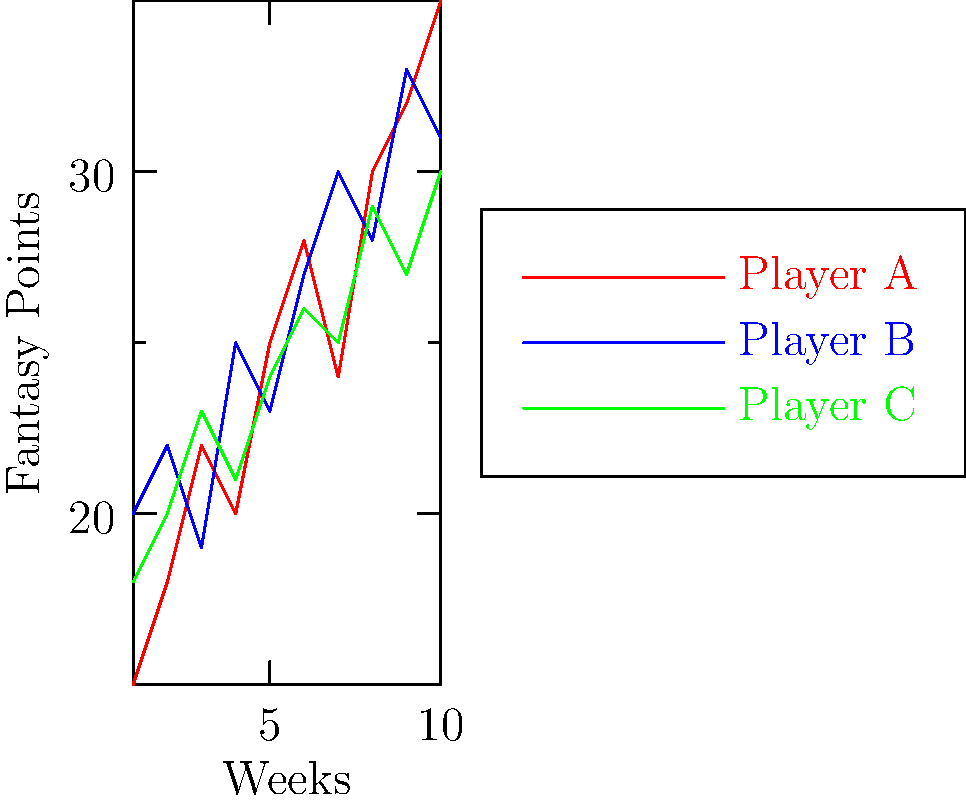Based on the line graph showing fantasy points earned over a 10-week season for three different players, which player had the highest average fantasy points per week? Calculate the average to the nearest tenth. To solve this problem, we need to follow these steps:

1. Calculate the total points for each player over the 10 weeks.
2. Divide the total points by 10 to get the average.
3. Compare the averages to determine the highest.

For Player A:
Total points = 15 + 18 + 22 + 20 + 25 + 28 + 24 + 30 + 32 + 35 = 249
Average = 249 / 10 = 24.9

For Player B:
Total points = 20 + 22 + 19 + 25 + 23 + 27 + 30 + 28 + 33 + 31 = 258
Average = 258 / 10 = 25.8

For Player C:
Total points = 18 + 20 + 23 + 21 + 24 + 26 + 25 + 29 + 27 + 30 = 243
Average = 243 / 10 = 24.3

Comparing the averages:
Player A: 24.9
Player B: 25.8
Player C: 24.3

Player B has the highest average at 25.8 fantasy points per week.
Answer: Player B, 25.8 points 